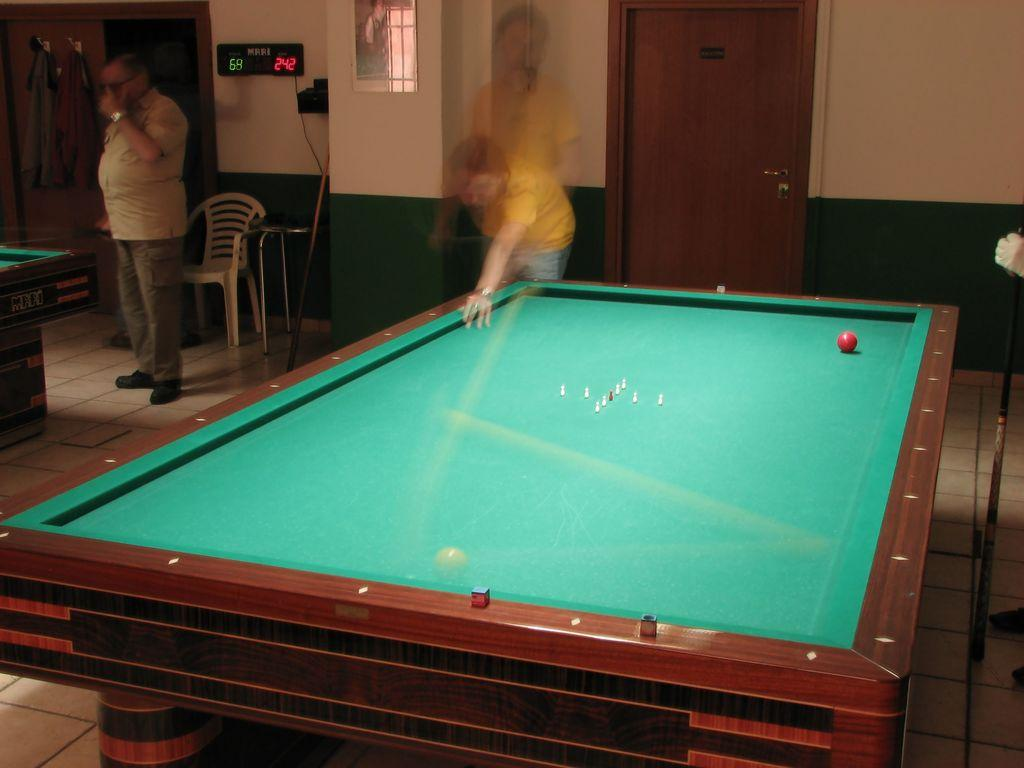What is the man doing in the image? The man is standing at a table on the left side of the image. What is located behind the man? There is a chair behind the man. What can be seen on the wall in the image? Clothes are hanging on the wall. What is visible in the background of the image? There is a door in the background. What is in the middle of the image? There is a board in the middle of the image. Can you describe the person standing by the board? The person standing by the board is blurry. What is the profit of the wheel in the image? There is no wheel present in the image, so it is not possible to determine its profit. 